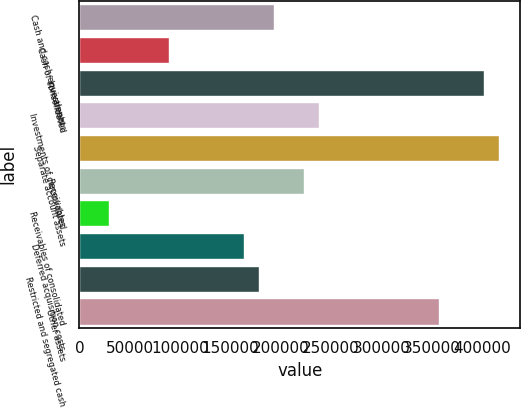<chart> <loc_0><loc_0><loc_500><loc_500><bar_chart><fcel>Cash and cash equivalents<fcel>Cash of consolidated<fcel>Investments<fcel>Investments of consolidated<fcel>Separate account assets<fcel>Receivables<fcel>Receivables of consolidated<fcel>Deferred acquisition costs<fcel>Restricted and segregated cash<fcel>Other assets<nl><fcel>193452<fcel>89287.2<fcel>401782<fcel>238094<fcel>416663<fcel>223214<fcel>29764.4<fcel>163691<fcel>178571<fcel>357140<nl></chart> 